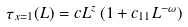Convert formula to latex. <formula><loc_0><loc_0><loc_500><loc_500>\tau _ { x = 1 } ( L ) = c L ^ { z } \, ( 1 + c _ { 1 1 } L ^ { - \omega } )</formula> 